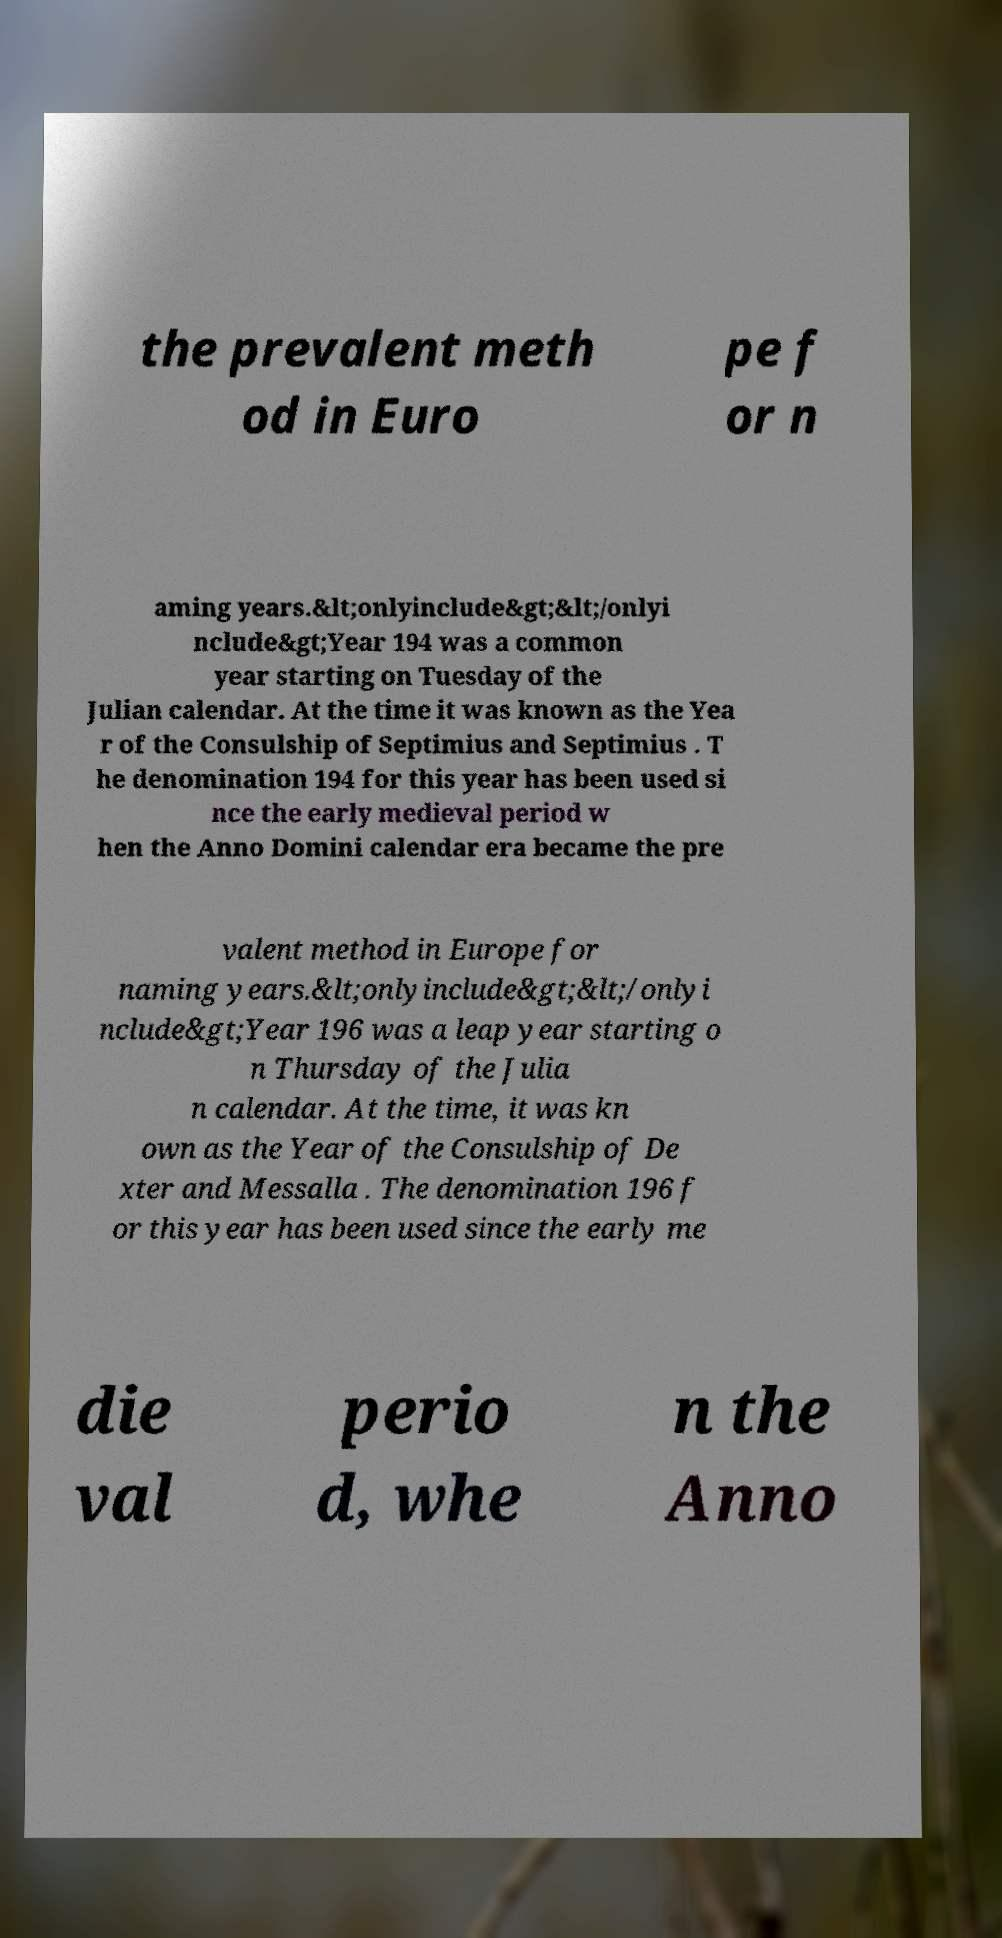Could you extract and type out the text from this image? the prevalent meth od in Euro pe f or n aming years.&lt;onlyinclude&gt;&lt;/onlyi nclude&gt;Year 194 was a common year starting on Tuesday of the Julian calendar. At the time it was known as the Yea r of the Consulship of Septimius and Septimius . T he denomination 194 for this year has been used si nce the early medieval period w hen the Anno Domini calendar era became the pre valent method in Europe for naming years.&lt;onlyinclude&gt;&lt;/onlyi nclude&gt;Year 196 was a leap year starting o n Thursday of the Julia n calendar. At the time, it was kn own as the Year of the Consulship of De xter and Messalla . The denomination 196 f or this year has been used since the early me die val perio d, whe n the Anno 